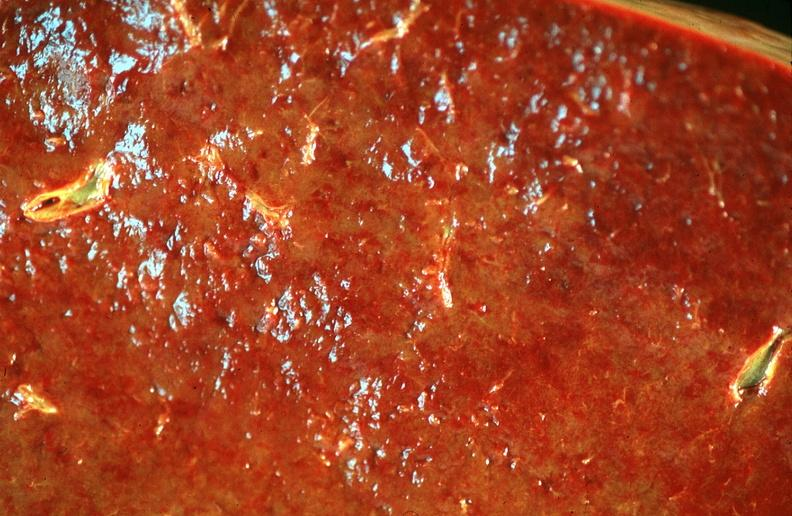does this image show spleen, chronic congestion due to portal hypertension from cirrhosis, hcv?
Answer the question using a single word or phrase. Yes 